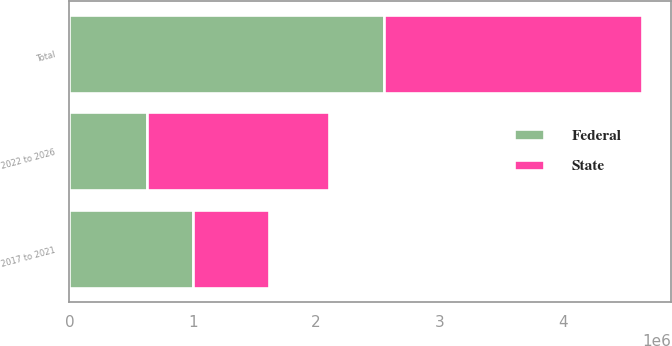Convert chart to OTSL. <chart><loc_0><loc_0><loc_500><loc_500><stacked_bar_chart><ecel><fcel>2017 to 2021<fcel>2022 to 2026<fcel>Total<nl><fcel>State<fcel>617039<fcel>1.47664e+06<fcel>2.09368e+06<nl><fcel>Federal<fcel>1.00179e+06<fcel>629354<fcel>2.54861e+06<nl></chart> 